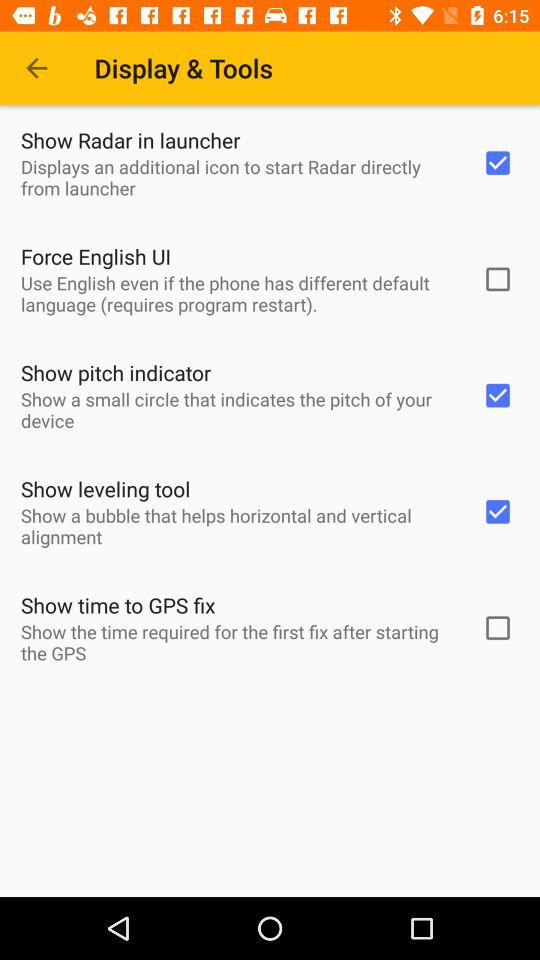How does the bubble help? The bubble helps in "horizontal and vertical alignment". 